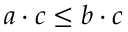Convert formula to latex. <formula><loc_0><loc_0><loc_500><loc_500>a \cdot c \leq b \cdot c</formula> 